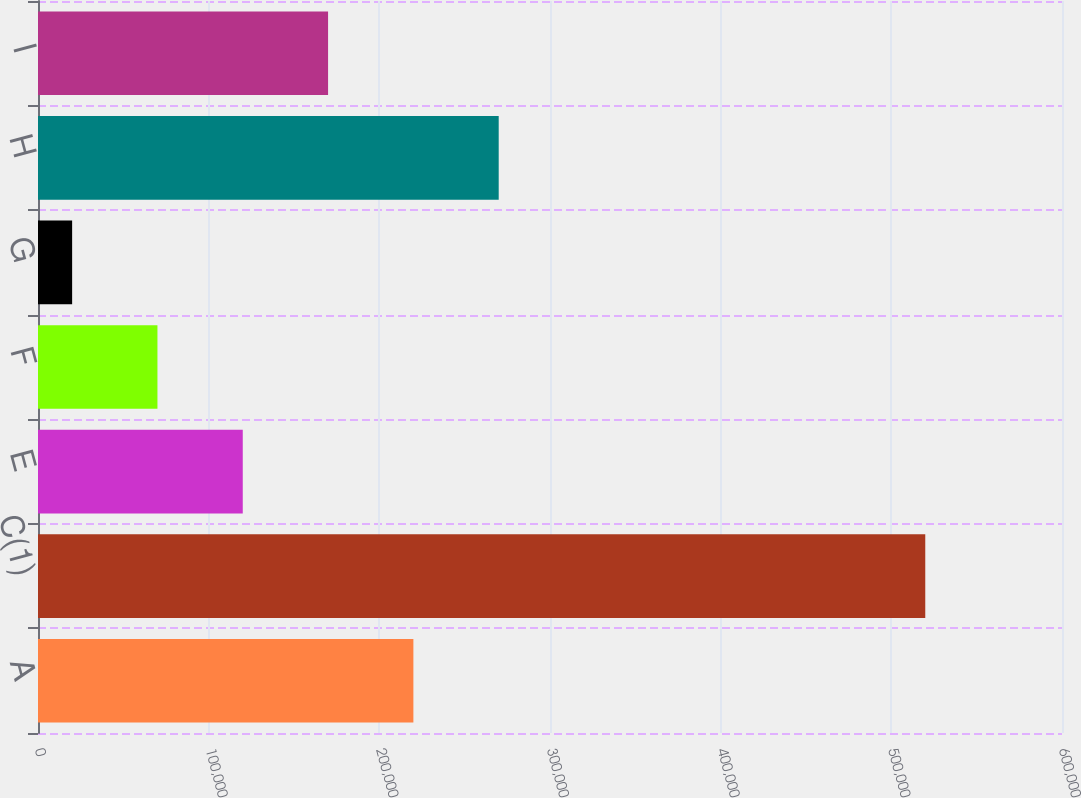<chart> <loc_0><loc_0><loc_500><loc_500><bar_chart><fcel>A<fcel>C(1)<fcel>E<fcel>F<fcel>G<fcel>H<fcel>I<nl><fcel>219953<fcel>519882<fcel>119976<fcel>69988.2<fcel>20000<fcel>269941<fcel>169965<nl></chart> 